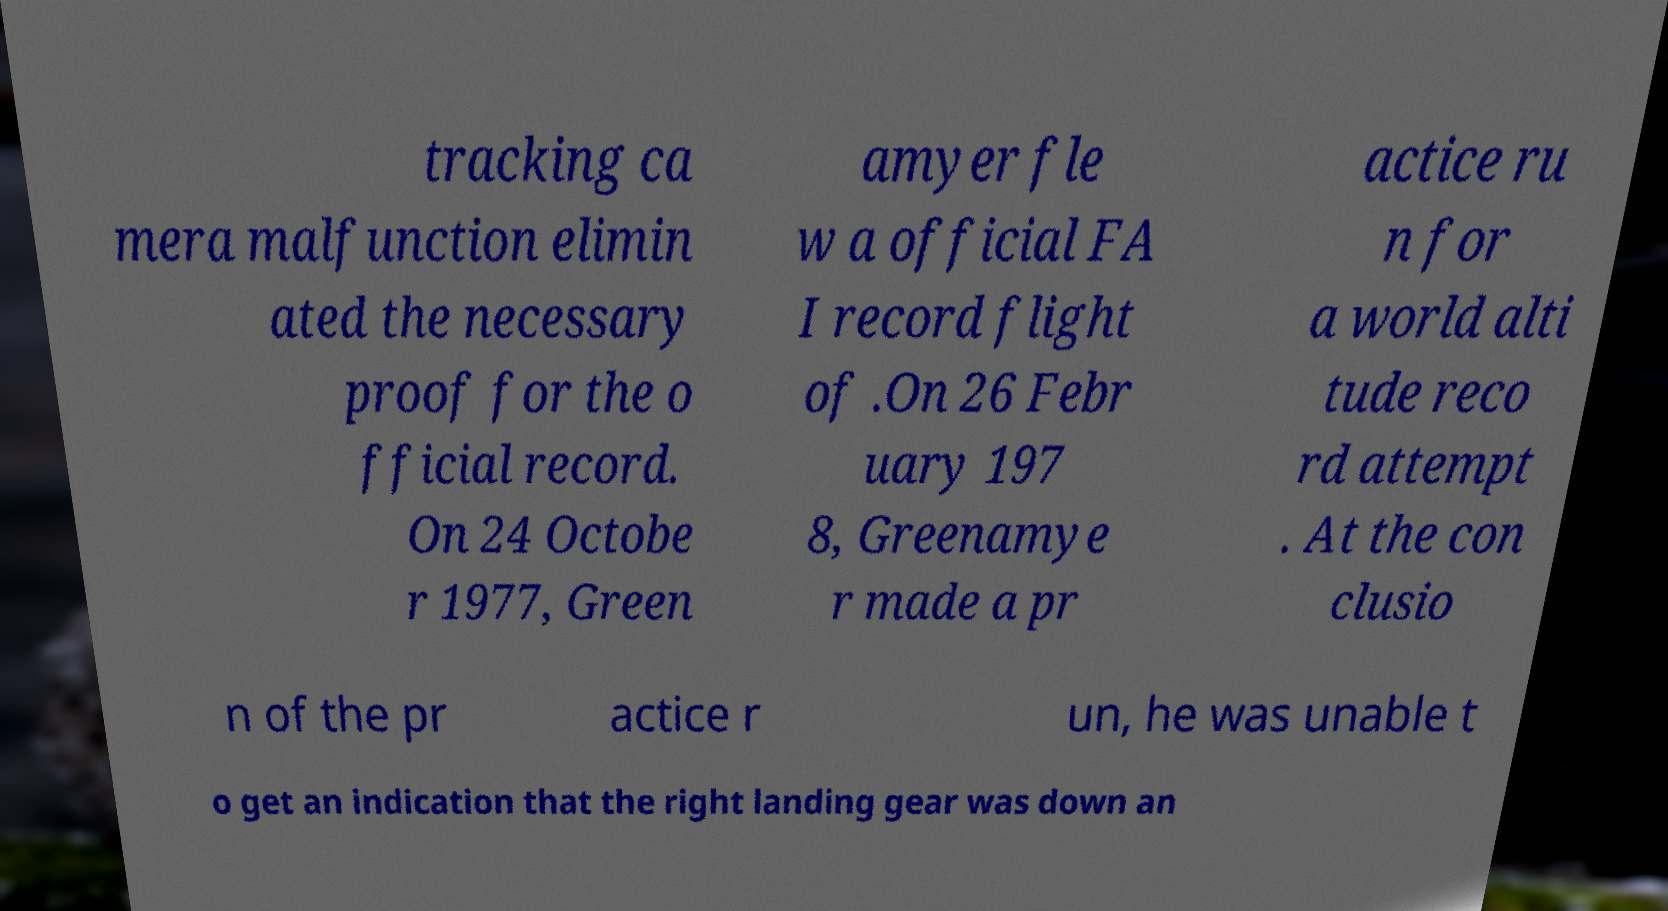Please identify and transcribe the text found in this image. tracking ca mera malfunction elimin ated the necessary proof for the o fficial record. On 24 Octobe r 1977, Green amyer fle w a official FA I record flight of .On 26 Febr uary 197 8, Greenamye r made a pr actice ru n for a world alti tude reco rd attempt . At the con clusio n of the pr actice r un, he was unable t o get an indication that the right landing gear was down an 